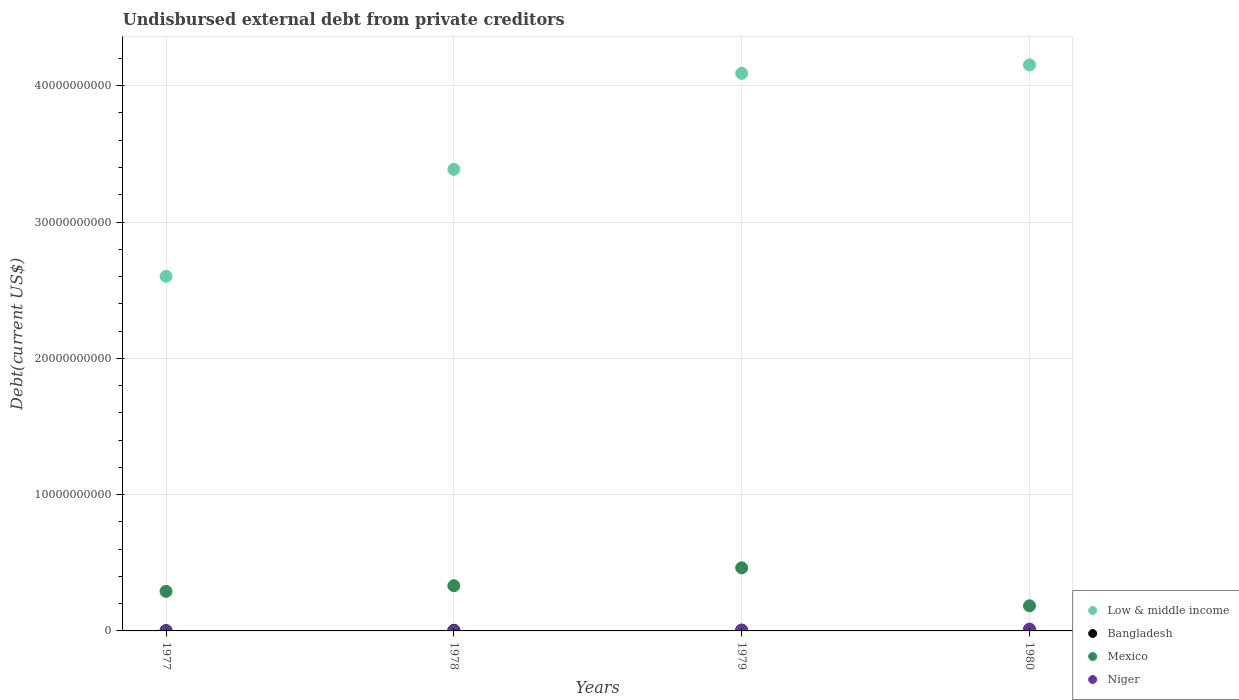What is the total debt in Bangladesh in 1978?
Offer a terse response. 4.38e+07. Across all years, what is the maximum total debt in Niger?
Provide a succinct answer. 1.36e+08. Across all years, what is the minimum total debt in Low & middle income?
Keep it short and to the point. 2.60e+1. In which year was the total debt in Mexico maximum?
Your answer should be very brief. 1979. In which year was the total debt in Niger minimum?
Keep it short and to the point. 1977. What is the total total debt in Bangladesh in the graph?
Offer a terse response. 1.52e+08. What is the difference between the total debt in Mexico in 1977 and that in 1980?
Your answer should be very brief. 1.06e+09. What is the difference between the total debt in Mexico in 1978 and the total debt in Niger in 1980?
Provide a succinct answer. 3.18e+09. What is the average total debt in Niger per year?
Give a very brief answer. 5.66e+07. In the year 1979, what is the difference between the total debt in Mexico and total debt in Bangladesh?
Offer a very short reply. 4.59e+09. In how many years, is the total debt in Bangladesh greater than 26000000000 US$?
Offer a very short reply. 0. What is the ratio of the total debt in Bangladesh in 1977 to that in 1978?
Your response must be concise. 0.46. What is the difference between the highest and the second highest total debt in Bangladesh?
Provide a succinct answer. 5.97e+06. What is the difference between the highest and the lowest total debt in Low & middle income?
Keep it short and to the point. 1.55e+1. Is it the case that in every year, the sum of the total debt in Mexico and total debt in Bangladesh  is greater than the sum of total debt in Low & middle income and total debt in Niger?
Make the answer very short. Yes. Is it the case that in every year, the sum of the total debt in Low & middle income and total debt in Niger  is greater than the total debt in Bangladesh?
Your answer should be very brief. Yes. Does the total debt in Niger monotonically increase over the years?
Offer a terse response. Yes. Is the total debt in Low & middle income strictly greater than the total debt in Bangladesh over the years?
Make the answer very short. Yes. How many years are there in the graph?
Offer a terse response. 4. What is the difference between two consecutive major ticks on the Y-axis?
Your answer should be very brief. 1.00e+1. Are the values on the major ticks of Y-axis written in scientific E-notation?
Offer a very short reply. No. Does the graph contain any zero values?
Your answer should be very brief. No. Does the graph contain grids?
Give a very brief answer. Yes. How many legend labels are there?
Make the answer very short. 4. What is the title of the graph?
Ensure brevity in your answer.  Undisbursed external debt from private creditors. What is the label or title of the Y-axis?
Provide a succinct answer. Debt(current US$). What is the Debt(current US$) of Low & middle income in 1977?
Your response must be concise. 2.60e+1. What is the Debt(current US$) of Bangladesh in 1977?
Your answer should be very brief. 1.99e+07. What is the Debt(current US$) of Mexico in 1977?
Provide a succinct answer. 2.90e+09. What is the Debt(current US$) in Niger in 1977?
Provide a succinct answer. 2.44e+06. What is the Debt(current US$) in Low & middle income in 1978?
Ensure brevity in your answer.  3.39e+1. What is the Debt(current US$) in Bangladesh in 1978?
Your response must be concise. 4.38e+07. What is the Debt(current US$) of Mexico in 1978?
Your answer should be compact. 3.32e+09. What is the Debt(current US$) of Niger in 1978?
Your answer should be compact. 2.09e+07. What is the Debt(current US$) of Low & middle income in 1979?
Offer a terse response. 4.09e+1. What is the Debt(current US$) in Bangladesh in 1979?
Offer a terse response. 3.82e+07. What is the Debt(current US$) of Mexico in 1979?
Offer a terse response. 4.63e+09. What is the Debt(current US$) in Niger in 1979?
Provide a succinct answer. 6.73e+07. What is the Debt(current US$) in Low & middle income in 1980?
Provide a succinct answer. 4.15e+1. What is the Debt(current US$) of Bangladesh in 1980?
Offer a terse response. 4.97e+07. What is the Debt(current US$) of Mexico in 1980?
Keep it short and to the point. 1.84e+09. What is the Debt(current US$) in Niger in 1980?
Give a very brief answer. 1.36e+08. Across all years, what is the maximum Debt(current US$) of Low & middle income?
Your answer should be compact. 4.15e+1. Across all years, what is the maximum Debt(current US$) in Bangladesh?
Give a very brief answer. 4.97e+07. Across all years, what is the maximum Debt(current US$) of Mexico?
Give a very brief answer. 4.63e+09. Across all years, what is the maximum Debt(current US$) of Niger?
Your answer should be very brief. 1.36e+08. Across all years, what is the minimum Debt(current US$) in Low & middle income?
Provide a short and direct response. 2.60e+1. Across all years, what is the minimum Debt(current US$) in Bangladesh?
Provide a succinct answer. 1.99e+07. Across all years, what is the minimum Debt(current US$) in Mexico?
Ensure brevity in your answer.  1.84e+09. Across all years, what is the minimum Debt(current US$) of Niger?
Ensure brevity in your answer.  2.44e+06. What is the total Debt(current US$) in Low & middle income in the graph?
Provide a succinct answer. 1.42e+11. What is the total Debt(current US$) in Bangladesh in the graph?
Offer a terse response. 1.52e+08. What is the total Debt(current US$) in Mexico in the graph?
Ensure brevity in your answer.  1.27e+1. What is the total Debt(current US$) of Niger in the graph?
Offer a terse response. 2.26e+08. What is the difference between the Debt(current US$) in Low & middle income in 1977 and that in 1978?
Provide a short and direct response. -7.84e+09. What is the difference between the Debt(current US$) in Bangladesh in 1977 and that in 1978?
Your answer should be very brief. -2.38e+07. What is the difference between the Debt(current US$) in Mexico in 1977 and that in 1978?
Provide a succinct answer. -4.14e+08. What is the difference between the Debt(current US$) of Niger in 1977 and that in 1978?
Make the answer very short. -1.85e+07. What is the difference between the Debt(current US$) in Low & middle income in 1977 and that in 1979?
Make the answer very short. -1.49e+1. What is the difference between the Debt(current US$) of Bangladesh in 1977 and that in 1979?
Your response must be concise. -1.83e+07. What is the difference between the Debt(current US$) in Mexico in 1977 and that in 1979?
Ensure brevity in your answer.  -1.73e+09. What is the difference between the Debt(current US$) of Niger in 1977 and that in 1979?
Keep it short and to the point. -6.48e+07. What is the difference between the Debt(current US$) in Low & middle income in 1977 and that in 1980?
Provide a succinct answer. -1.55e+1. What is the difference between the Debt(current US$) in Bangladesh in 1977 and that in 1980?
Your answer should be very brief. -2.98e+07. What is the difference between the Debt(current US$) in Mexico in 1977 and that in 1980?
Offer a very short reply. 1.06e+09. What is the difference between the Debt(current US$) of Niger in 1977 and that in 1980?
Your answer should be very brief. -1.33e+08. What is the difference between the Debt(current US$) of Low & middle income in 1978 and that in 1979?
Offer a very short reply. -7.05e+09. What is the difference between the Debt(current US$) of Bangladesh in 1978 and that in 1979?
Offer a terse response. 5.53e+06. What is the difference between the Debt(current US$) of Mexico in 1978 and that in 1979?
Ensure brevity in your answer.  -1.31e+09. What is the difference between the Debt(current US$) in Niger in 1978 and that in 1979?
Your response must be concise. -4.63e+07. What is the difference between the Debt(current US$) of Low & middle income in 1978 and that in 1980?
Provide a succinct answer. -7.66e+09. What is the difference between the Debt(current US$) in Bangladesh in 1978 and that in 1980?
Offer a very short reply. -5.97e+06. What is the difference between the Debt(current US$) in Mexico in 1978 and that in 1980?
Offer a very short reply. 1.48e+09. What is the difference between the Debt(current US$) in Niger in 1978 and that in 1980?
Your response must be concise. -1.15e+08. What is the difference between the Debt(current US$) in Low & middle income in 1979 and that in 1980?
Provide a short and direct response. -6.17e+08. What is the difference between the Debt(current US$) of Bangladesh in 1979 and that in 1980?
Give a very brief answer. -1.15e+07. What is the difference between the Debt(current US$) in Mexico in 1979 and that in 1980?
Ensure brevity in your answer.  2.79e+09. What is the difference between the Debt(current US$) of Niger in 1979 and that in 1980?
Give a very brief answer. -6.83e+07. What is the difference between the Debt(current US$) of Low & middle income in 1977 and the Debt(current US$) of Bangladesh in 1978?
Keep it short and to the point. 2.60e+1. What is the difference between the Debt(current US$) in Low & middle income in 1977 and the Debt(current US$) in Mexico in 1978?
Your answer should be very brief. 2.27e+1. What is the difference between the Debt(current US$) of Low & middle income in 1977 and the Debt(current US$) of Niger in 1978?
Make the answer very short. 2.60e+1. What is the difference between the Debt(current US$) of Bangladesh in 1977 and the Debt(current US$) of Mexico in 1978?
Provide a succinct answer. -3.30e+09. What is the difference between the Debt(current US$) of Bangladesh in 1977 and the Debt(current US$) of Niger in 1978?
Provide a short and direct response. -9.87e+05. What is the difference between the Debt(current US$) in Mexico in 1977 and the Debt(current US$) in Niger in 1978?
Ensure brevity in your answer.  2.88e+09. What is the difference between the Debt(current US$) of Low & middle income in 1977 and the Debt(current US$) of Bangladesh in 1979?
Offer a terse response. 2.60e+1. What is the difference between the Debt(current US$) in Low & middle income in 1977 and the Debt(current US$) in Mexico in 1979?
Make the answer very short. 2.14e+1. What is the difference between the Debt(current US$) of Low & middle income in 1977 and the Debt(current US$) of Niger in 1979?
Your answer should be very brief. 2.60e+1. What is the difference between the Debt(current US$) of Bangladesh in 1977 and the Debt(current US$) of Mexico in 1979?
Offer a terse response. -4.61e+09. What is the difference between the Debt(current US$) in Bangladesh in 1977 and the Debt(current US$) in Niger in 1979?
Provide a succinct answer. -4.73e+07. What is the difference between the Debt(current US$) in Mexico in 1977 and the Debt(current US$) in Niger in 1979?
Your response must be concise. 2.84e+09. What is the difference between the Debt(current US$) in Low & middle income in 1977 and the Debt(current US$) in Bangladesh in 1980?
Your answer should be compact. 2.60e+1. What is the difference between the Debt(current US$) in Low & middle income in 1977 and the Debt(current US$) in Mexico in 1980?
Keep it short and to the point. 2.42e+1. What is the difference between the Debt(current US$) of Low & middle income in 1977 and the Debt(current US$) of Niger in 1980?
Offer a terse response. 2.59e+1. What is the difference between the Debt(current US$) in Bangladesh in 1977 and the Debt(current US$) in Mexico in 1980?
Keep it short and to the point. -1.82e+09. What is the difference between the Debt(current US$) in Bangladesh in 1977 and the Debt(current US$) in Niger in 1980?
Keep it short and to the point. -1.16e+08. What is the difference between the Debt(current US$) in Mexico in 1977 and the Debt(current US$) in Niger in 1980?
Your answer should be very brief. 2.77e+09. What is the difference between the Debt(current US$) of Low & middle income in 1978 and the Debt(current US$) of Bangladesh in 1979?
Keep it short and to the point. 3.38e+1. What is the difference between the Debt(current US$) in Low & middle income in 1978 and the Debt(current US$) in Mexico in 1979?
Your response must be concise. 2.92e+1. What is the difference between the Debt(current US$) in Low & middle income in 1978 and the Debt(current US$) in Niger in 1979?
Keep it short and to the point. 3.38e+1. What is the difference between the Debt(current US$) of Bangladesh in 1978 and the Debt(current US$) of Mexico in 1979?
Your response must be concise. -4.58e+09. What is the difference between the Debt(current US$) in Bangladesh in 1978 and the Debt(current US$) in Niger in 1979?
Your response must be concise. -2.35e+07. What is the difference between the Debt(current US$) of Mexico in 1978 and the Debt(current US$) of Niger in 1979?
Provide a succinct answer. 3.25e+09. What is the difference between the Debt(current US$) in Low & middle income in 1978 and the Debt(current US$) in Bangladesh in 1980?
Your answer should be very brief. 3.38e+1. What is the difference between the Debt(current US$) in Low & middle income in 1978 and the Debt(current US$) in Mexico in 1980?
Make the answer very short. 3.20e+1. What is the difference between the Debt(current US$) of Low & middle income in 1978 and the Debt(current US$) of Niger in 1980?
Ensure brevity in your answer.  3.37e+1. What is the difference between the Debt(current US$) in Bangladesh in 1978 and the Debt(current US$) in Mexico in 1980?
Ensure brevity in your answer.  -1.80e+09. What is the difference between the Debt(current US$) in Bangladesh in 1978 and the Debt(current US$) in Niger in 1980?
Make the answer very short. -9.18e+07. What is the difference between the Debt(current US$) in Mexico in 1978 and the Debt(current US$) in Niger in 1980?
Offer a very short reply. 3.18e+09. What is the difference between the Debt(current US$) of Low & middle income in 1979 and the Debt(current US$) of Bangladesh in 1980?
Ensure brevity in your answer.  4.09e+1. What is the difference between the Debt(current US$) of Low & middle income in 1979 and the Debt(current US$) of Mexico in 1980?
Keep it short and to the point. 3.91e+1. What is the difference between the Debt(current US$) of Low & middle income in 1979 and the Debt(current US$) of Niger in 1980?
Offer a terse response. 4.08e+1. What is the difference between the Debt(current US$) of Bangladesh in 1979 and the Debt(current US$) of Mexico in 1980?
Give a very brief answer. -1.80e+09. What is the difference between the Debt(current US$) of Bangladesh in 1979 and the Debt(current US$) of Niger in 1980?
Your answer should be compact. -9.74e+07. What is the difference between the Debt(current US$) in Mexico in 1979 and the Debt(current US$) in Niger in 1980?
Offer a terse response. 4.49e+09. What is the average Debt(current US$) in Low & middle income per year?
Your answer should be very brief. 3.56e+1. What is the average Debt(current US$) of Bangladesh per year?
Make the answer very short. 3.79e+07. What is the average Debt(current US$) of Mexico per year?
Ensure brevity in your answer.  3.17e+09. What is the average Debt(current US$) in Niger per year?
Keep it short and to the point. 5.66e+07. In the year 1977, what is the difference between the Debt(current US$) of Low & middle income and Debt(current US$) of Bangladesh?
Provide a succinct answer. 2.60e+1. In the year 1977, what is the difference between the Debt(current US$) in Low & middle income and Debt(current US$) in Mexico?
Your response must be concise. 2.31e+1. In the year 1977, what is the difference between the Debt(current US$) of Low & middle income and Debt(current US$) of Niger?
Make the answer very short. 2.60e+1. In the year 1977, what is the difference between the Debt(current US$) in Bangladesh and Debt(current US$) in Mexico?
Provide a short and direct response. -2.88e+09. In the year 1977, what is the difference between the Debt(current US$) of Bangladesh and Debt(current US$) of Niger?
Ensure brevity in your answer.  1.75e+07. In the year 1977, what is the difference between the Debt(current US$) in Mexico and Debt(current US$) in Niger?
Make the answer very short. 2.90e+09. In the year 1978, what is the difference between the Debt(current US$) in Low & middle income and Debt(current US$) in Bangladesh?
Offer a terse response. 3.38e+1. In the year 1978, what is the difference between the Debt(current US$) in Low & middle income and Debt(current US$) in Mexico?
Ensure brevity in your answer.  3.05e+1. In the year 1978, what is the difference between the Debt(current US$) in Low & middle income and Debt(current US$) in Niger?
Your answer should be very brief. 3.38e+1. In the year 1978, what is the difference between the Debt(current US$) of Bangladesh and Debt(current US$) of Mexico?
Ensure brevity in your answer.  -3.27e+09. In the year 1978, what is the difference between the Debt(current US$) in Bangladesh and Debt(current US$) in Niger?
Offer a very short reply. 2.28e+07. In the year 1978, what is the difference between the Debt(current US$) of Mexico and Debt(current US$) of Niger?
Your answer should be very brief. 3.30e+09. In the year 1979, what is the difference between the Debt(current US$) in Low & middle income and Debt(current US$) in Bangladesh?
Offer a very short reply. 4.09e+1. In the year 1979, what is the difference between the Debt(current US$) of Low & middle income and Debt(current US$) of Mexico?
Your answer should be compact. 3.63e+1. In the year 1979, what is the difference between the Debt(current US$) of Low & middle income and Debt(current US$) of Niger?
Your response must be concise. 4.08e+1. In the year 1979, what is the difference between the Debt(current US$) in Bangladesh and Debt(current US$) in Mexico?
Your response must be concise. -4.59e+09. In the year 1979, what is the difference between the Debt(current US$) in Bangladesh and Debt(current US$) in Niger?
Give a very brief answer. -2.90e+07. In the year 1979, what is the difference between the Debt(current US$) in Mexico and Debt(current US$) in Niger?
Offer a terse response. 4.56e+09. In the year 1980, what is the difference between the Debt(current US$) of Low & middle income and Debt(current US$) of Bangladesh?
Provide a short and direct response. 4.15e+1. In the year 1980, what is the difference between the Debt(current US$) in Low & middle income and Debt(current US$) in Mexico?
Your answer should be compact. 3.97e+1. In the year 1980, what is the difference between the Debt(current US$) of Low & middle income and Debt(current US$) of Niger?
Offer a very short reply. 4.14e+1. In the year 1980, what is the difference between the Debt(current US$) in Bangladesh and Debt(current US$) in Mexico?
Give a very brief answer. -1.79e+09. In the year 1980, what is the difference between the Debt(current US$) in Bangladesh and Debt(current US$) in Niger?
Provide a short and direct response. -8.59e+07. In the year 1980, what is the difference between the Debt(current US$) of Mexico and Debt(current US$) of Niger?
Ensure brevity in your answer.  1.71e+09. What is the ratio of the Debt(current US$) in Low & middle income in 1977 to that in 1978?
Your answer should be compact. 0.77. What is the ratio of the Debt(current US$) of Bangladesh in 1977 to that in 1978?
Provide a succinct answer. 0.46. What is the ratio of the Debt(current US$) in Mexico in 1977 to that in 1978?
Offer a terse response. 0.88. What is the ratio of the Debt(current US$) of Niger in 1977 to that in 1978?
Offer a very short reply. 0.12. What is the ratio of the Debt(current US$) of Low & middle income in 1977 to that in 1979?
Offer a very short reply. 0.64. What is the ratio of the Debt(current US$) of Bangladesh in 1977 to that in 1979?
Offer a terse response. 0.52. What is the ratio of the Debt(current US$) in Mexico in 1977 to that in 1979?
Provide a succinct answer. 0.63. What is the ratio of the Debt(current US$) of Niger in 1977 to that in 1979?
Offer a terse response. 0.04. What is the ratio of the Debt(current US$) in Low & middle income in 1977 to that in 1980?
Provide a succinct answer. 0.63. What is the ratio of the Debt(current US$) of Bangladesh in 1977 to that in 1980?
Provide a short and direct response. 0.4. What is the ratio of the Debt(current US$) of Mexico in 1977 to that in 1980?
Provide a short and direct response. 1.58. What is the ratio of the Debt(current US$) of Niger in 1977 to that in 1980?
Keep it short and to the point. 0.02. What is the ratio of the Debt(current US$) in Low & middle income in 1978 to that in 1979?
Keep it short and to the point. 0.83. What is the ratio of the Debt(current US$) in Bangladesh in 1978 to that in 1979?
Your answer should be compact. 1.14. What is the ratio of the Debt(current US$) of Mexico in 1978 to that in 1979?
Offer a very short reply. 0.72. What is the ratio of the Debt(current US$) in Niger in 1978 to that in 1979?
Make the answer very short. 0.31. What is the ratio of the Debt(current US$) in Low & middle income in 1978 to that in 1980?
Your response must be concise. 0.82. What is the ratio of the Debt(current US$) of Mexico in 1978 to that in 1980?
Provide a short and direct response. 1.8. What is the ratio of the Debt(current US$) of Niger in 1978 to that in 1980?
Your answer should be very brief. 0.15. What is the ratio of the Debt(current US$) of Low & middle income in 1979 to that in 1980?
Your answer should be compact. 0.99. What is the ratio of the Debt(current US$) of Bangladesh in 1979 to that in 1980?
Keep it short and to the point. 0.77. What is the ratio of the Debt(current US$) in Mexico in 1979 to that in 1980?
Your answer should be very brief. 2.51. What is the ratio of the Debt(current US$) of Niger in 1979 to that in 1980?
Offer a terse response. 0.5. What is the difference between the highest and the second highest Debt(current US$) in Low & middle income?
Ensure brevity in your answer.  6.17e+08. What is the difference between the highest and the second highest Debt(current US$) of Bangladesh?
Keep it short and to the point. 5.97e+06. What is the difference between the highest and the second highest Debt(current US$) of Mexico?
Provide a short and direct response. 1.31e+09. What is the difference between the highest and the second highest Debt(current US$) in Niger?
Your answer should be compact. 6.83e+07. What is the difference between the highest and the lowest Debt(current US$) in Low & middle income?
Your answer should be very brief. 1.55e+1. What is the difference between the highest and the lowest Debt(current US$) of Bangladesh?
Provide a succinct answer. 2.98e+07. What is the difference between the highest and the lowest Debt(current US$) of Mexico?
Make the answer very short. 2.79e+09. What is the difference between the highest and the lowest Debt(current US$) of Niger?
Your answer should be very brief. 1.33e+08. 